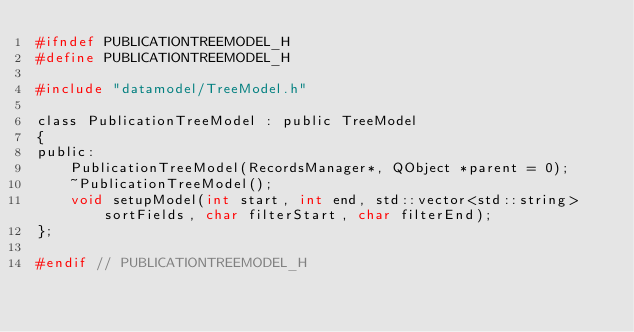<code> <loc_0><loc_0><loc_500><loc_500><_C_>#ifndef PUBLICATIONTREEMODEL_H
#define PUBLICATIONTREEMODEL_H

#include "datamodel/TreeModel.h"

class PublicationTreeModel : public TreeModel
{
public:
    PublicationTreeModel(RecordsManager*, QObject *parent = 0);
    ~PublicationTreeModel();
    void setupModel(int start, int end, std::vector<std::string> sortFields, char filterStart, char filterEnd);
};

#endif // PUBLICATIONTREEMODEL_H
</code> 